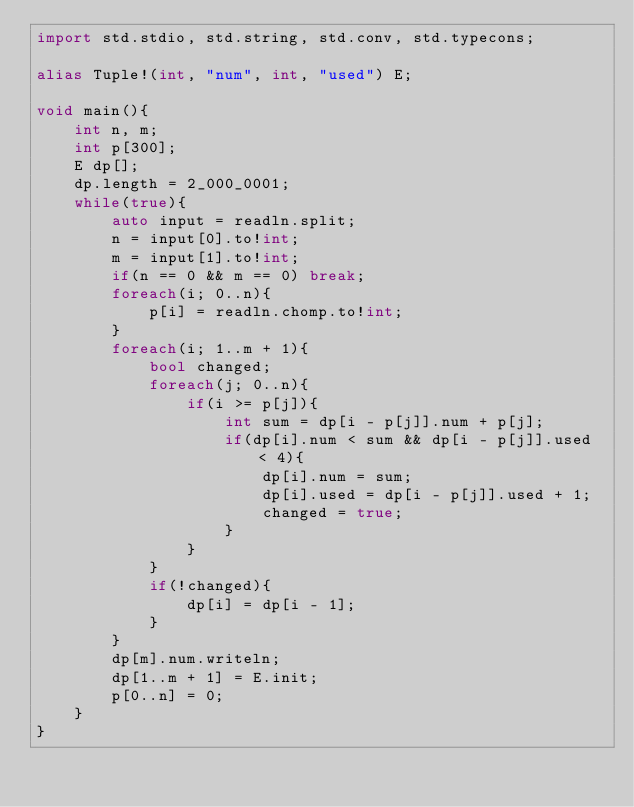Convert code to text. <code><loc_0><loc_0><loc_500><loc_500><_D_>import std.stdio, std.string, std.conv, std.typecons;

alias Tuple!(int, "num", int, "used") E;

void main(){
    int n, m;
    int p[300];
    E dp[];
    dp.length = 2_000_0001;
    while(true){
        auto input = readln.split;
        n = input[0].to!int;
        m = input[1].to!int;
        if(n == 0 && m == 0) break;
        foreach(i; 0..n){
            p[i] = readln.chomp.to!int;
        }
        foreach(i; 1..m + 1){
            bool changed;
            foreach(j; 0..n){
                if(i >= p[j]){
                    int sum = dp[i - p[j]].num + p[j];
                    if(dp[i].num < sum && dp[i - p[j]].used < 4){
                        dp[i].num = sum;
                        dp[i].used = dp[i - p[j]].used + 1;
                        changed = true;
                    }
                }
            }
            if(!changed){
                dp[i] = dp[i - 1];
            }
        }
        dp[m].num.writeln;
        dp[1..m + 1] = E.init;
        p[0..n] = 0;
    }
}</code> 